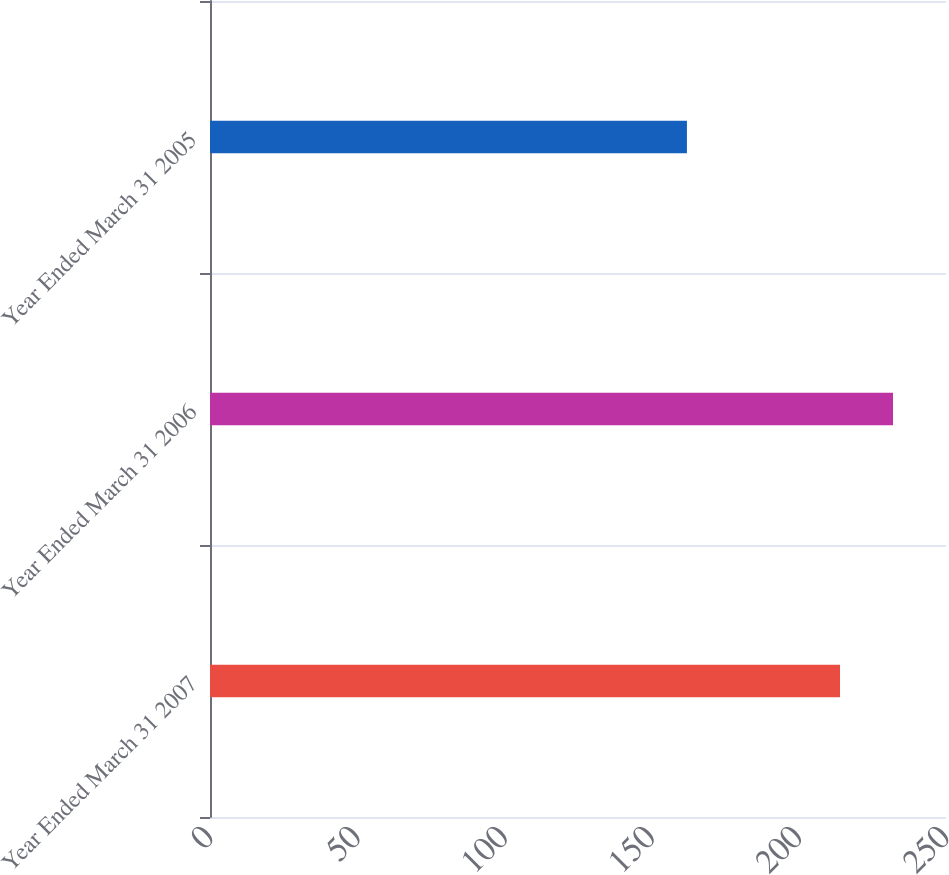Convert chart. <chart><loc_0><loc_0><loc_500><loc_500><bar_chart><fcel>Year Ended March 31 2007<fcel>Year Ended March 31 2006<fcel>Year Ended March 31 2005<nl><fcel>214<fcel>232<fcel>162<nl></chart> 